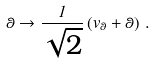<formula> <loc_0><loc_0><loc_500><loc_500>\theta \to \frac { 1 } { \sqrt { 2 } } \left ( v _ { \theta } + \theta \right ) \, .</formula> 